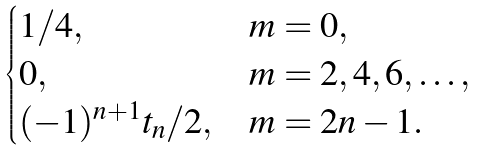Convert formula to latex. <formula><loc_0><loc_0><loc_500><loc_500>\begin{cases} 1 / 4 , & m = 0 , \\ 0 , & m = 2 , 4 , 6 , \dots , \\ ( - 1 ) ^ { n + 1 } t _ { n } / 2 , & m = 2 n - 1 . \end{cases}</formula> 